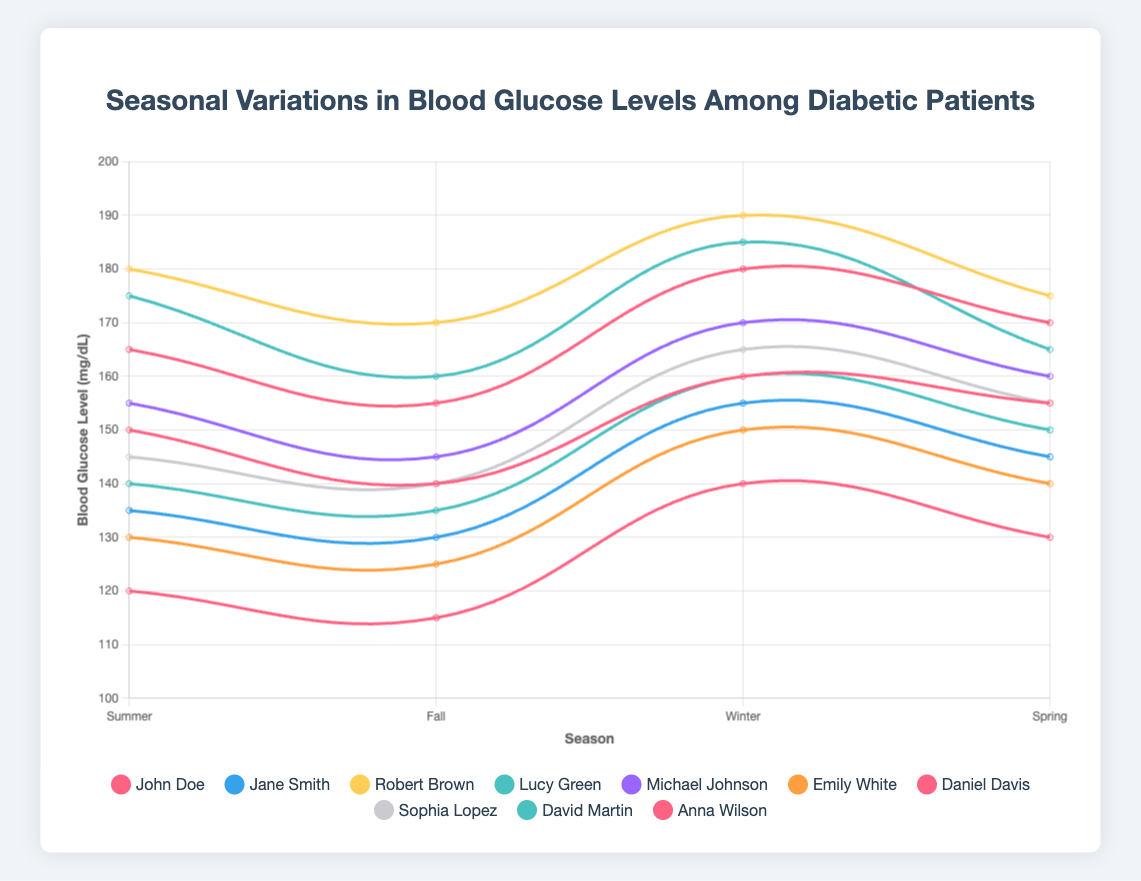Which patient has the highest blood glucose level in Winter? Patient 003, Robert Brown, has the highest blood glucose level of 190 mg/dL in Winter, as indicated by the peak of his curve during this season.
Answer: Robert Brown What is the overall trend in blood glucose levels for patient Anna Wilson across the seasons? For Anna Wilson, the blood glucose level shows a gradual increase from Fall (115 mg/dL) to Winter (140 mg/dL) and then slightly decreases in Spring (130 mg/dL), with the highest value in Winter.
Answer: Increasing then decreasing Compare the blood glucose levels in Summer between Daniel Davis and David Martin. Who has the higher value? Daniel Davis has a blood glucose level of 165 mg/dL in Summer, while David Martin has a level of 175 mg/dL. Therefore, David Martin has the higher value.
Answer: David Martin Which season shows the lowest average blood glucose level among all patients? Calculate the average for each season: Summer (149.5 mg/dL), Fall (137.5 mg/dL), Winter (163.5 mg/dL), and Spring (154.5 mg/dL). Fall has the lowest average blood glucose level of 137.5 mg/dL.
Answer: Fall What is the difference in blood glucose levels between Summer and Winter for Emily White? Emily White has a blood glucose level of 130 mg/dL in Summer and 150 mg/dL in Winter. The difference is 150 - 130 = 20 mg/dL.
Answer: 20 mg/dL Which patient experiences the most significant fluctuation in blood glucose levels between seasons? Calculate the range (max - min) for each patient: the highest fluctuation is in Patient 009, David Martin, ranging from 115 mg/dL in Fall to 185 mg/dL in Winter, a difference of 70 mg/dL.
Answer: David Martin What is the combined blood glucose level of John Doe and Michael Johnson in Spring? John Doe has a blood glucose level of 155 mg/dL and Michael Johnson has 160 mg/dL in Spring. Combined, this is 155 + 160 = 315 mg/dL.
Answer: 315 mg/dL How do the blood glucose levels of Sophia Lopez change from Summer to Fall? Sophia Lopez’s blood glucose level drops from 145 mg/dL in Summer to 140 mg/dL in Fall, indicating a slight decrease of 5 mg/dL.
Answer: Decrease by 5 mg/dL 